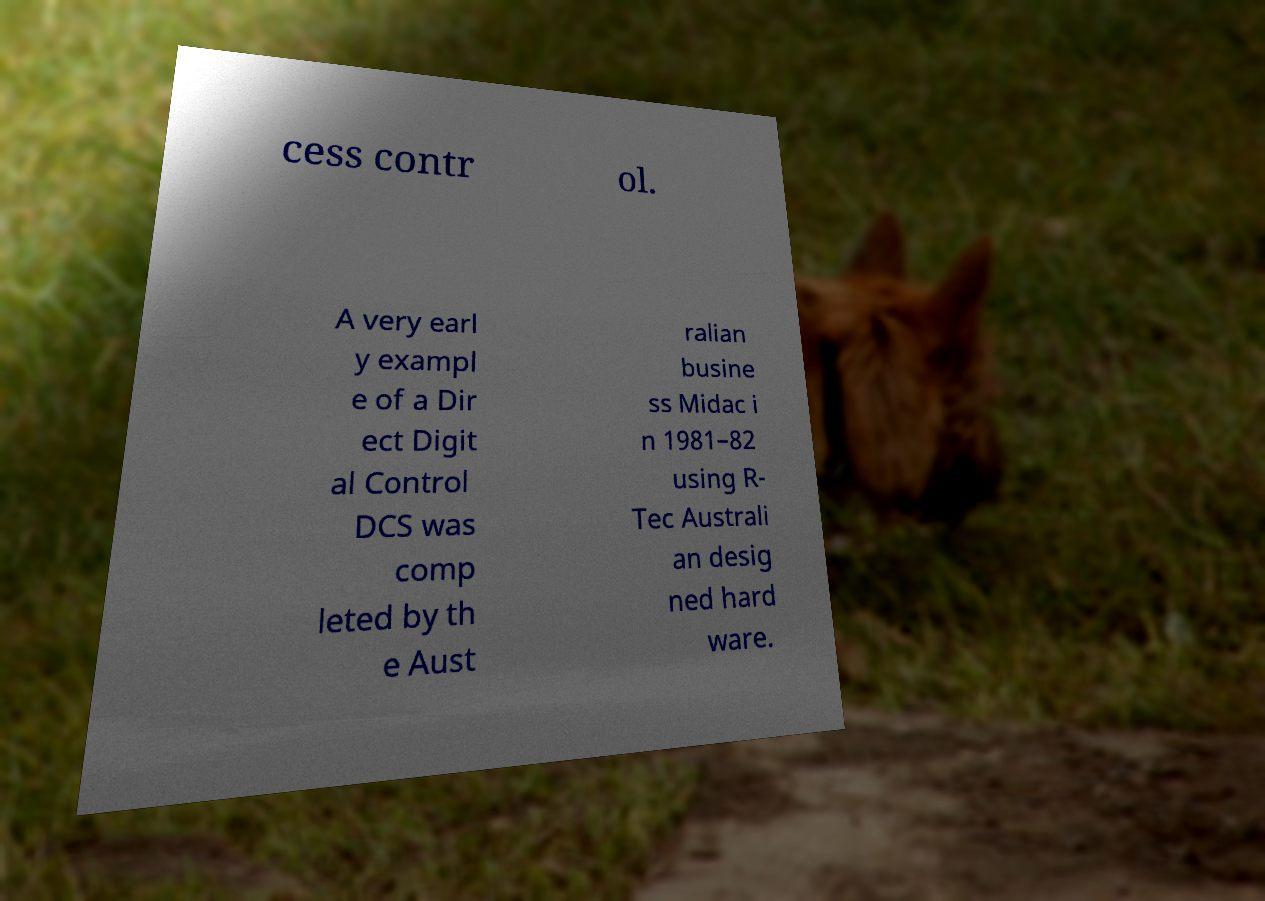There's text embedded in this image that I need extracted. Can you transcribe it verbatim? cess contr ol. A very earl y exampl e of a Dir ect Digit al Control DCS was comp leted by th e Aust ralian busine ss Midac i n 1981–82 using R- Tec Australi an desig ned hard ware. 